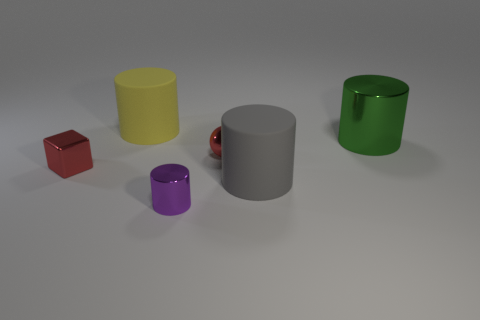Subtract all big gray cylinders. How many cylinders are left? 3 Add 4 metal cylinders. How many objects exist? 10 Subtract all purple cylinders. How many cylinders are left? 3 Subtract all cubes. How many objects are left? 5 Subtract 2 cylinders. How many cylinders are left? 2 Subtract all green cubes. Subtract all green spheres. How many cubes are left? 1 Subtract all purple cubes. How many purple balls are left? 0 Subtract all yellow blocks. Subtract all tiny blocks. How many objects are left? 5 Add 5 metallic objects. How many metallic objects are left? 9 Add 6 red spheres. How many red spheres exist? 7 